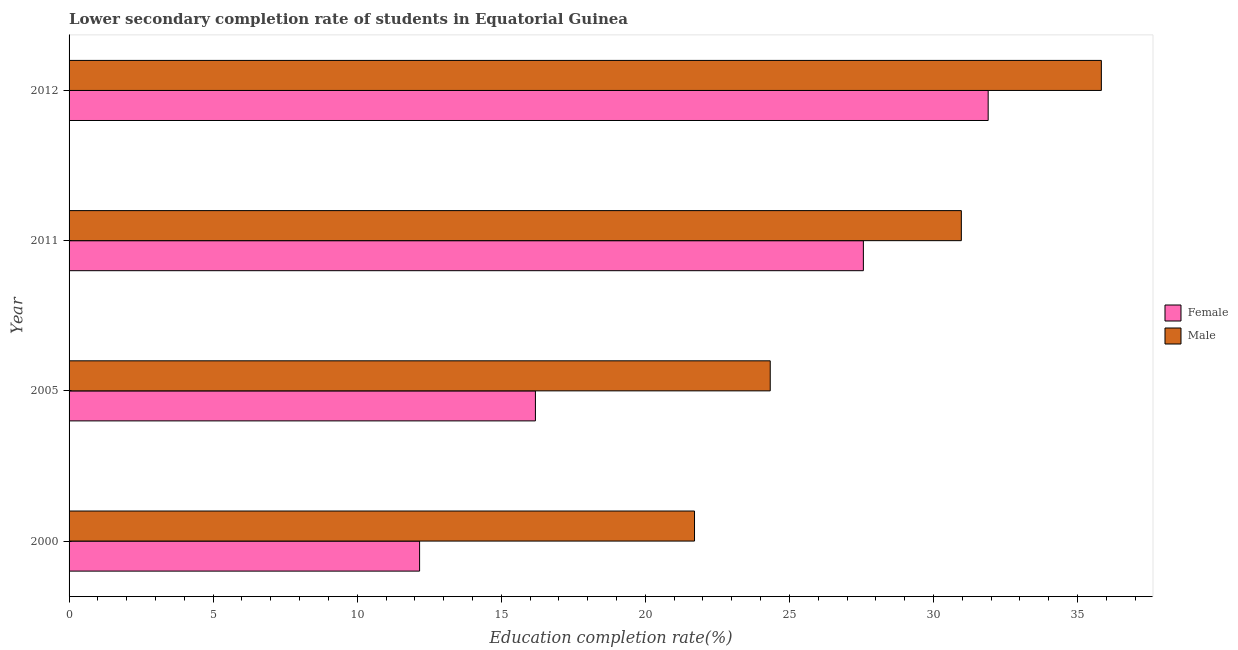How many different coloured bars are there?
Your answer should be very brief. 2. How many bars are there on the 3rd tick from the bottom?
Give a very brief answer. 2. What is the label of the 2nd group of bars from the top?
Keep it short and to the point. 2011. What is the education completion rate of male students in 2005?
Provide a succinct answer. 24.33. Across all years, what is the maximum education completion rate of male students?
Make the answer very short. 35.83. Across all years, what is the minimum education completion rate of female students?
Your answer should be compact. 12.17. In which year was the education completion rate of male students maximum?
Make the answer very short. 2012. In which year was the education completion rate of female students minimum?
Offer a very short reply. 2000. What is the total education completion rate of female students in the graph?
Make the answer very short. 87.82. What is the difference between the education completion rate of female students in 2000 and that in 2005?
Your answer should be very brief. -4.02. What is the difference between the education completion rate of male students in 2012 and the education completion rate of female students in 2011?
Your response must be concise. 8.26. What is the average education completion rate of male students per year?
Ensure brevity in your answer.  28.21. What is the ratio of the education completion rate of male students in 2005 to that in 2011?
Your answer should be very brief. 0.79. Is the education completion rate of female students in 2000 less than that in 2005?
Your answer should be compact. Yes. Is the difference between the education completion rate of male students in 2000 and 2012 greater than the difference between the education completion rate of female students in 2000 and 2012?
Your response must be concise. Yes. What is the difference between the highest and the second highest education completion rate of female students?
Your answer should be very brief. 4.33. What is the difference between the highest and the lowest education completion rate of female students?
Give a very brief answer. 19.73. What does the 2nd bar from the bottom in 2000 represents?
Provide a short and direct response. Male. How many bars are there?
Keep it short and to the point. 8. How many years are there in the graph?
Your response must be concise. 4. What is the title of the graph?
Make the answer very short. Lower secondary completion rate of students in Equatorial Guinea. What is the label or title of the X-axis?
Your answer should be compact. Education completion rate(%). What is the label or title of the Y-axis?
Your answer should be very brief. Year. What is the Education completion rate(%) in Female in 2000?
Your answer should be very brief. 12.17. What is the Education completion rate(%) in Male in 2000?
Provide a short and direct response. 21.71. What is the Education completion rate(%) in Female in 2005?
Ensure brevity in your answer.  16.18. What is the Education completion rate(%) of Male in 2005?
Your answer should be compact. 24.33. What is the Education completion rate(%) of Female in 2011?
Make the answer very short. 27.57. What is the Education completion rate(%) of Male in 2011?
Offer a very short reply. 30.97. What is the Education completion rate(%) in Female in 2012?
Offer a terse response. 31.9. What is the Education completion rate(%) of Male in 2012?
Your answer should be very brief. 35.83. Across all years, what is the maximum Education completion rate(%) of Female?
Keep it short and to the point. 31.9. Across all years, what is the maximum Education completion rate(%) in Male?
Provide a succinct answer. 35.83. Across all years, what is the minimum Education completion rate(%) in Female?
Keep it short and to the point. 12.17. Across all years, what is the minimum Education completion rate(%) of Male?
Give a very brief answer. 21.71. What is the total Education completion rate(%) of Female in the graph?
Offer a terse response. 87.81. What is the total Education completion rate(%) of Male in the graph?
Offer a very short reply. 112.83. What is the difference between the Education completion rate(%) in Female in 2000 and that in 2005?
Your answer should be compact. -4.02. What is the difference between the Education completion rate(%) of Male in 2000 and that in 2005?
Provide a short and direct response. -2.63. What is the difference between the Education completion rate(%) in Female in 2000 and that in 2011?
Ensure brevity in your answer.  -15.4. What is the difference between the Education completion rate(%) of Male in 2000 and that in 2011?
Offer a terse response. -9.26. What is the difference between the Education completion rate(%) of Female in 2000 and that in 2012?
Ensure brevity in your answer.  -19.73. What is the difference between the Education completion rate(%) of Male in 2000 and that in 2012?
Provide a succinct answer. -14.12. What is the difference between the Education completion rate(%) of Female in 2005 and that in 2011?
Your response must be concise. -11.38. What is the difference between the Education completion rate(%) in Male in 2005 and that in 2011?
Your answer should be very brief. -6.63. What is the difference between the Education completion rate(%) of Female in 2005 and that in 2012?
Offer a very short reply. -15.71. What is the difference between the Education completion rate(%) in Male in 2005 and that in 2012?
Offer a very short reply. -11.49. What is the difference between the Education completion rate(%) in Female in 2011 and that in 2012?
Your answer should be very brief. -4.33. What is the difference between the Education completion rate(%) in Male in 2011 and that in 2012?
Offer a very short reply. -4.86. What is the difference between the Education completion rate(%) of Female in 2000 and the Education completion rate(%) of Male in 2005?
Keep it short and to the point. -12.17. What is the difference between the Education completion rate(%) in Female in 2000 and the Education completion rate(%) in Male in 2011?
Offer a terse response. -18.8. What is the difference between the Education completion rate(%) in Female in 2000 and the Education completion rate(%) in Male in 2012?
Provide a succinct answer. -23.66. What is the difference between the Education completion rate(%) in Female in 2005 and the Education completion rate(%) in Male in 2011?
Your response must be concise. -14.78. What is the difference between the Education completion rate(%) in Female in 2005 and the Education completion rate(%) in Male in 2012?
Keep it short and to the point. -19.64. What is the difference between the Education completion rate(%) of Female in 2011 and the Education completion rate(%) of Male in 2012?
Make the answer very short. -8.26. What is the average Education completion rate(%) of Female per year?
Your answer should be compact. 21.95. What is the average Education completion rate(%) of Male per year?
Offer a very short reply. 28.21. In the year 2000, what is the difference between the Education completion rate(%) of Female and Education completion rate(%) of Male?
Give a very brief answer. -9.54. In the year 2005, what is the difference between the Education completion rate(%) in Female and Education completion rate(%) in Male?
Give a very brief answer. -8.15. In the year 2011, what is the difference between the Education completion rate(%) in Female and Education completion rate(%) in Male?
Your answer should be very brief. -3.4. In the year 2012, what is the difference between the Education completion rate(%) in Female and Education completion rate(%) in Male?
Offer a terse response. -3.93. What is the ratio of the Education completion rate(%) of Female in 2000 to that in 2005?
Your response must be concise. 0.75. What is the ratio of the Education completion rate(%) in Male in 2000 to that in 2005?
Ensure brevity in your answer.  0.89. What is the ratio of the Education completion rate(%) in Female in 2000 to that in 2011?
Keep it short and to the point. 0.44. What is the ratio of the Education completion rate(%) in Male in 2000 to that in 2011?
Give a very brief answer. 0.7. What is the ratio of the Education completion rate(%) of Female in 2000 to that in 2012?
Keep it short and to the point. 0.38. What is the ratio of the Education completion rate(%) of Male in 2000 to that in 2012?
Keep it short and to the point. 0.61. What is the ratio of the Education completion rate(%) of Female in 2005 to that in 2011?
Offer a very short reply. 0.59. What is the ratio of the Education completion rate(%) in Male in 2005 to that in 2011?
Your answer should be compact. 0.79. What is the ratio of the Education completion rate(%) of Female in 2005 to that in 2012?
Keep it short and to the point. 0.51. What is the ratio of the Education completion rate(%) of Male in 2005 to that in 2012?
Your answer should be very brief. 0.68. What is the ratio of the Education completion rate(%) of Female in 2011 to that in 2012?
Ensure brevity in your answer.  0.86. What is the ratio of the Education completion rate(%) of Male in 2011 to that in 2012?
Your answer should be compact. 0.86. What is the difference between the highest and the second highest Education completion rate(%) in Female?
Make the answer very short. 4.33. What is the difference between the highest and the second highest Education completion rate(%) of Male?
Offer a very short reply. 4.86. What is the difference between the highest and the lowest Education completion rate(%) of Female?
Your answer should be very brief. 19.73. What is the difference between the highest and the lowest Education completion rate(%) of Male?
Keep it short and to the point. 14.12. 